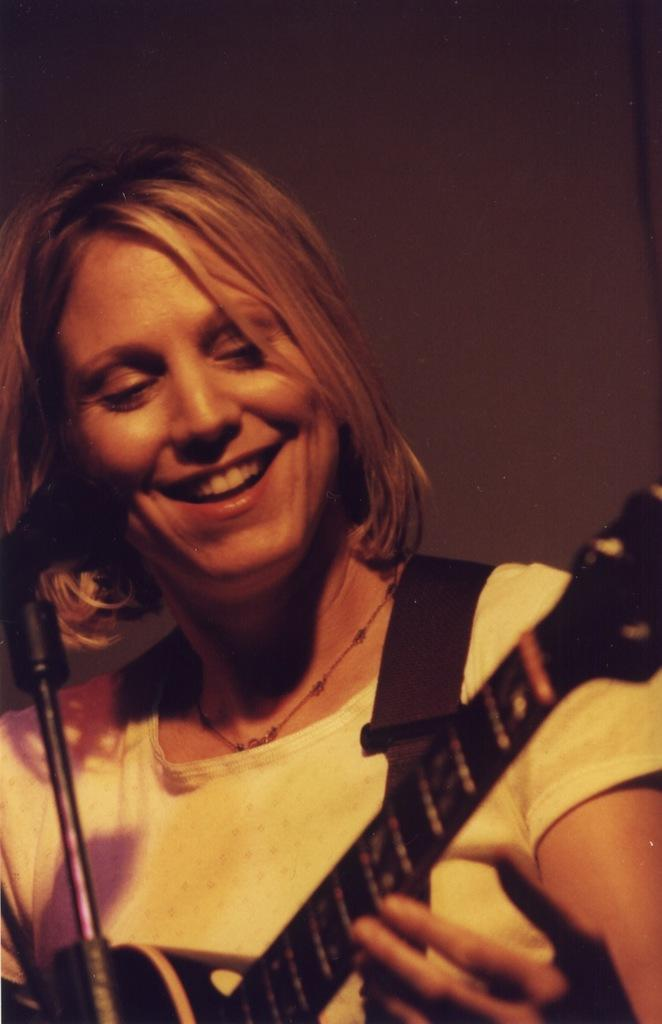Who is present in the image? There is a woman in the image. What is the woman doing in the image? The woman is smiling and holding a guitar. What can be seen in the background of the image? There is a wall in the background of the image. What type of leather is the woman wearing in the image? There is no leather visible in the image; the woman is not wearing any clothing that would be made of leather. 